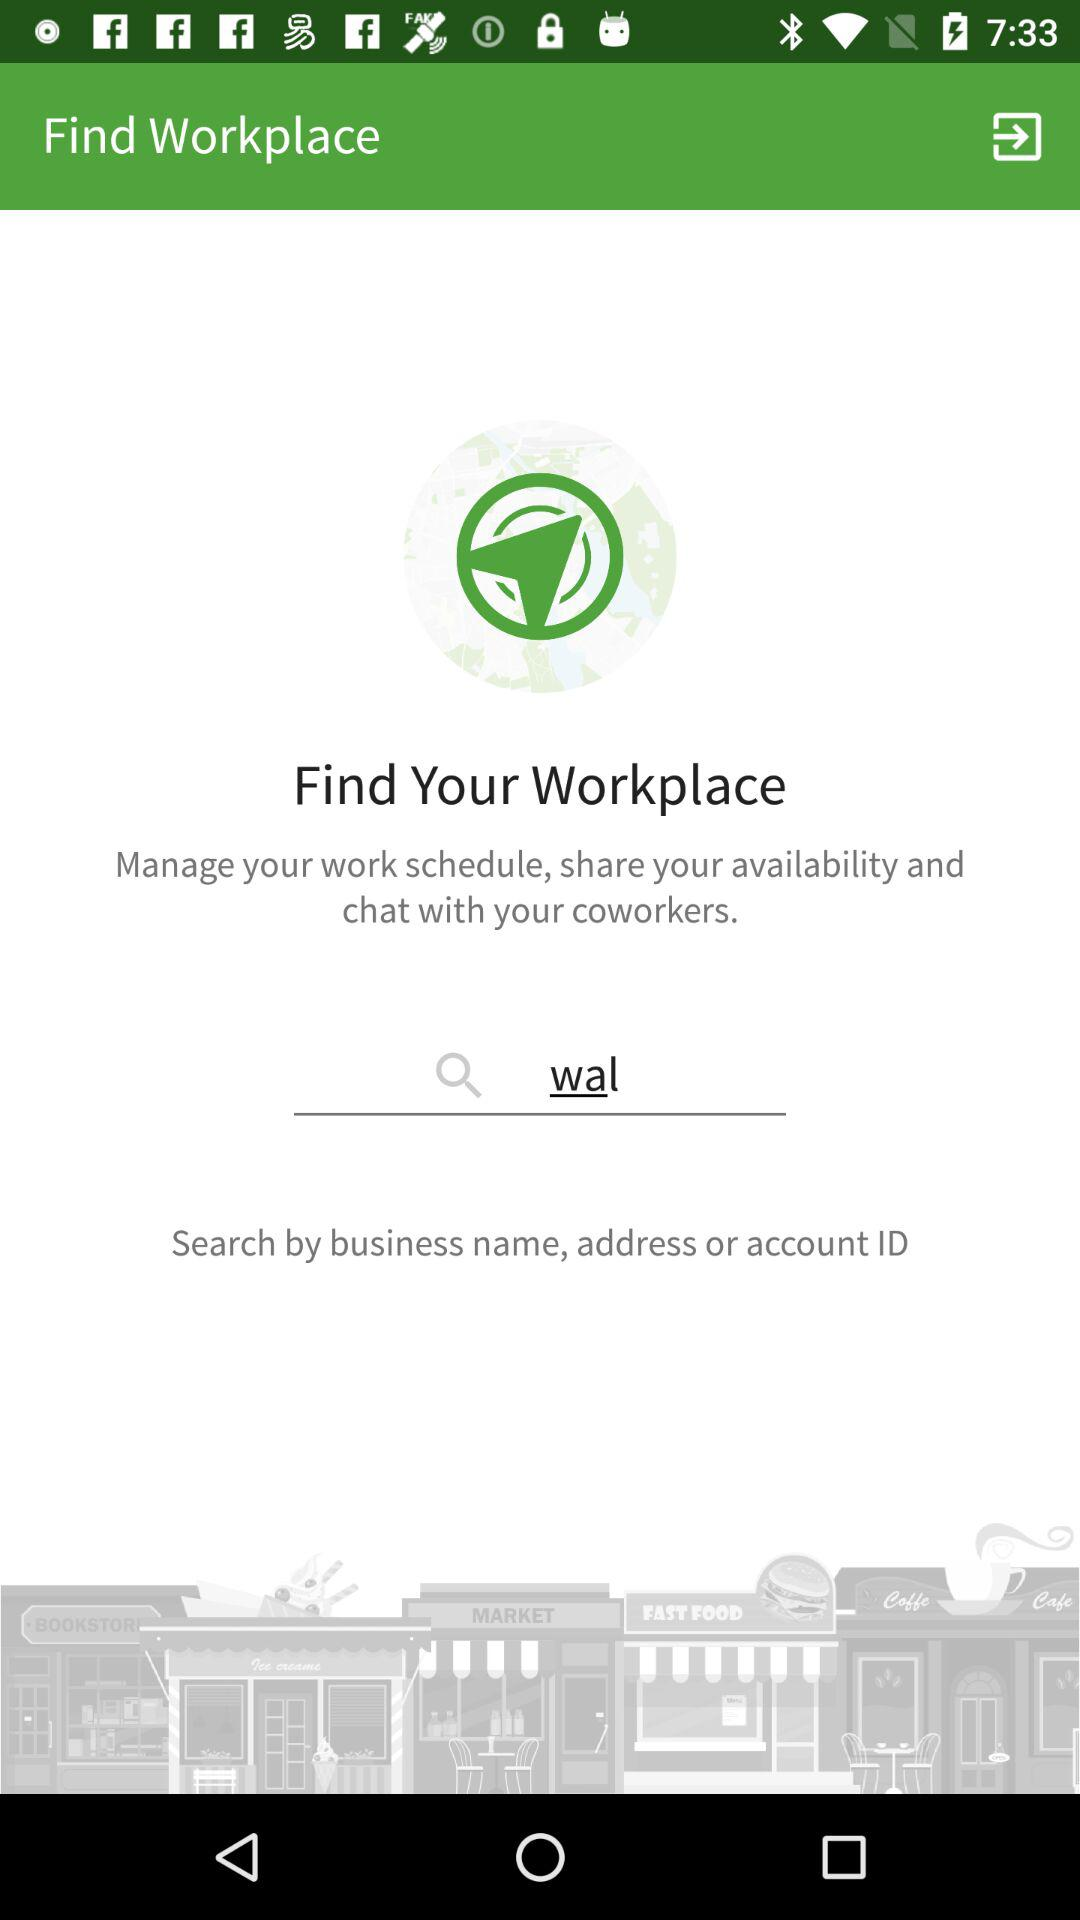By whom can we search? You can search by business name, address or account ID. 